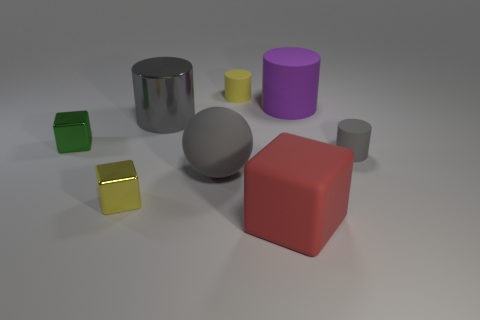What is the shape of the other big thing that is the same color as the big shiny object? sphere 